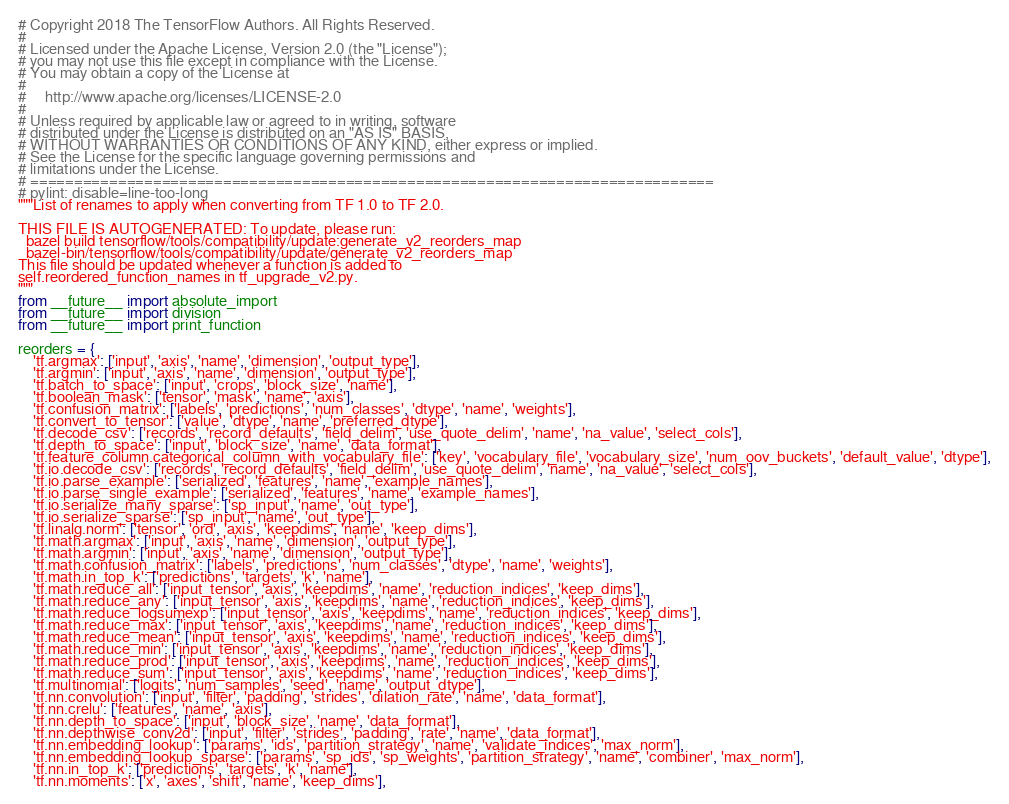Convert code to text. <code><loc_0><loc_0><loc_500><loc_500><_Python_># Copyright 2018 The TensorFlow Authors. All Rights Reserved.
#
# Licensed under the Apache License, Version 2.0 (the "License");
# you may not use this file except in compliance with the License.
# You may obtain a copy of the License at
#
#     http://www.apache.org/licenses/LICENSE-2.0
#
# Unless required by applicable law or agreed to in writing, software
# distributed under the License is distributed on an "AS IS" BASIS,
# WITHOUT WARRANTIES OR CONDITIONS OF ANY KIND, either express or implied.
# See the License for the specific language governing permissions and
# limitations under the License.
# ==============================================================================
# pylint: disable=line-too-long
"""List of renames to apply when converting from TF 1.0 to TF 2.0.

THIS FILE IS AUTOGENERATED: To update, please run:
  bazel build tensorflow/tools/compatibility/update:generate_v2_reorders_map
  bazel-bin/tensorflow/tools/compatibility/update/generate_v2_reorders_map
This file should be updated whenever a function is added to
self.reordered_function_names in tf_upgrade_v2.py.
"""
from __future__ import absolute_import
from __future__ import division
from __future__ import print_function

reorders = {
    'tf.argmax': ['input', 'axis', 'name', 'dimension', 'output_type'],
    'tf.argmin': ['input', 'axis', 'name', 'dimension', 'output_type'],
    'tf.batch_to_space': ['input', 'crops', 'block_size', 'name'],
    'tf.boolean_mask': ['tensor', 'mask', 'name', 'axis'],
    'tf.confusion_matrix': ['labels', 'predictions', 'num_classes', 'dtype', 'name', 'weights'],
    'tf.convert_to_tensor': ['value', 'dtype', 'name', 'preferred_dtype'],
    'tf.decode_csv': ['records', 'record_defaults', 'field_delim', 'use_quote_delim', 'name', 'na_value', 'select_cols'],
    'tf.depth_to_space': ['input', 'block_size', 'name', 'data_format'],
    'tf.feature_column.categorical_column_with_vocabulary_file': ['key', 'vocabulary_file', 'vocabulary_size', 'num_oov_buckets', 'default_value', 'dtype'],
    'tf.io.decode_csv': ['records', 'record_defaults', 'field_delim', 'use_quote_delim', 'name', 'na_value', 'select_cols'],
    'tf.io.parse_example': ['serialized', 'features', 'name', 'example_names'],
    'tf.io.parse_single_example': ['serialized', 'features', 'name', 'example_names'],
    'tf.io.serialize_many_sparse': ['sp_input', 'name', 'out_type'],
    'tf.io.serialize_sparse': ['sp_input', 'name', 'out_type'],
    'tf.linalg.norm': ['tensor', 'ord', 'axis', 'keepdims', 'name', 'keep_dims'],
    'tf.math.argmax': ['input', 'axis', 'name', 'dimension', 'output_type'],
    'tf.math.argmin': ['input', 'axis', 'name', 'dimension', 'output_type'],
    'tf.math.confusion_matrix': ['labels', 'predictions', 'num_classes', 'dtype', 'name', 'weights'],
    'tf.math.in_top_k': ['predictions', 'targets', 'k', 'name'],
    'tf.math.reduce_all': ['input_tensor', 'axis', 'keepdims', 'name', 'reduction_indices', 'keep_dims'],
    'tf.math.reduce_any': ['input_tensor', 'axis', 'keepdims', 'name', 'reduction_indices', 'keep_dims'],
    'tf.math.reduce_logsumexp': ['input_tensor', 'axis', 'keepdims', 'name', 'reduction_indices', 'keep_dims'],
    'tf.math.reduce_max': ['input_tensor', 'axis', 'keepdims', 'name', 'reduction_indices', 'keep_dims'],
    'tf.math.reduce_mean': ['input_tensor', 'axis', 'keepdims', 'name', 'reduction_indices', 'keep_dims'],
    'tf.math.reduce_min': ['input_tensor', 'axis', 'keepdims', 'name', 'reduction_indices', 'keep_dims'],
    'tf.math.reduce_prod': ['input_tensor', 'axis', 'keepdims', 'name', 'reduction_indices', 'keep_dims'],
    'tf.math.reduce_sum': ['input_tensor', 'axis', 'keepdims', 'name', 'reduction_indices', 'keep_dims'],
    'tf.multinomial': ['logits', 'num_samples', 'seed', 'name', 'output_dtype'],
    'tf.nn.convolution': ['input', 'filter', 'padding', 'strides', 'dilation_rate', 'name', 'data_format'],
    'tf.nn.crelu': ['features', 'name', 'axis'],
    'tf.nn.depth_to_space': ['input', 'block_size', 'name', 'data_format'],
    'tf.nn.depthwise_conv2d': ['input', 'filter', 'strides', 'padding', 'rate', 'name', 'data_format'],
    'tf.nn.embedding_lookup': ['params', 'ids', 'partition_strategy', 'name', 'validate_indices', 'max_norm'],
    'tf.nn.embedding_lookup_sparse': ['params', 'sp_ids', 'sp_weights', 'partition_strategy', 'name', 'combiner', 'max_norm'],
    'tf.nn.in_top_k': ['predictions', 'targets', 'k', 'name'],
    'tf.nn.moments': ['x', 'axes', 'shift', 'name', 'keep_dims'],</code> 